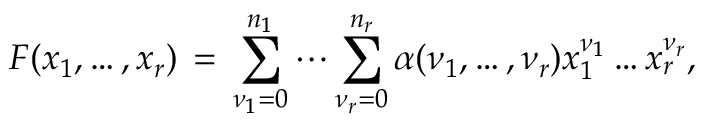Convert formula to latex. <formula><loc_0><loc_0><loc_500><loc_500>F ( x _ { 1 } , \dots , x _ { r } ) \, = \, \sum _ { \nu _ { 1 } = 0 } ^ { n _ { 1 } } \cdots \sum _ { \nu _ { r } = 0 } ^ { n _ { r } } \alpha ( \nu _ { 1 } , \dots , \nu _ { r } ) x _ { 1 } ^ { \nu _ { 1 } } \dots x _ { r } ^ { \nu _ { r } } ,</formula> 